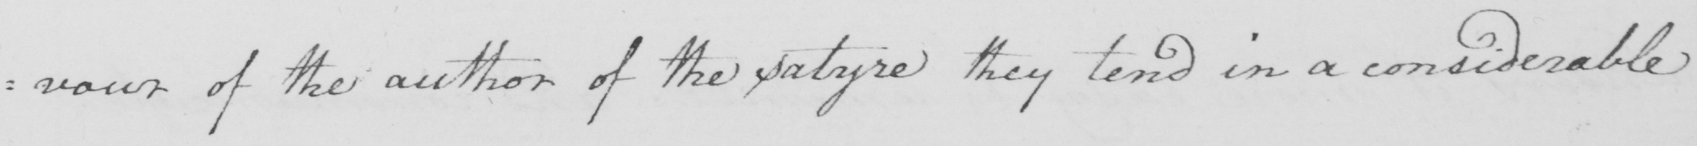Please transcribe the handwritten text in this image. of the author of the satyre they tend in a considerable 